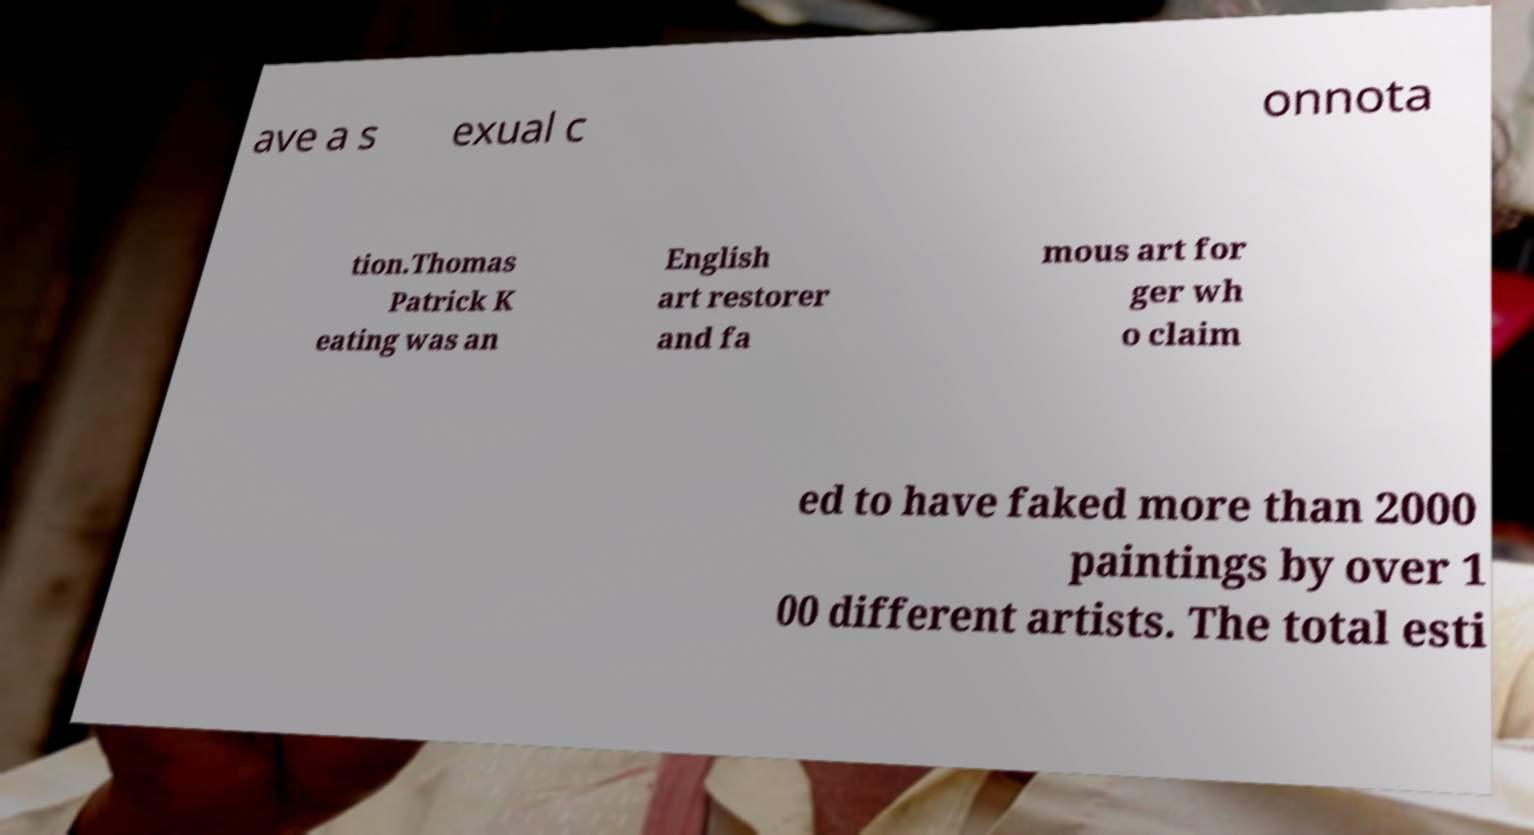What messages or text are displayed in this image? I need them in a readable, typed format. ave a s exual c onnota tion.Thomas Patrick K eating was an English art restorer and fa mous art for ger wh o claim ed to have faked more than 2000 paintings by over 1 00 different artists. The total esti 